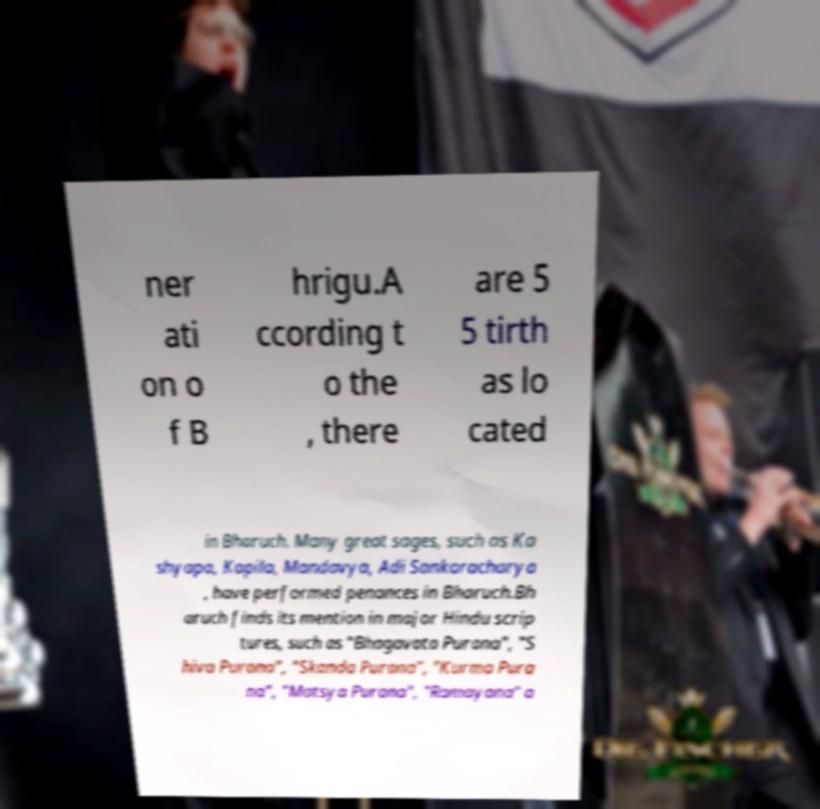Could you extract and type out the text from this image? ner ati on o f B hrigu.A ccording t o the , there are 5 5 tirth as lo cated in Bharuch. Many great sages, such as Ka shyapa, Kapila, Mandavya, Adi Sankaracharya , have performed penances in Bharuch.Bh aruch finds its mention in major Hindu scrip tures, such as "Bhagavata Purana", "S hiva Purana", "Skanda Purana", "Kurma Pura na", "Matsya Purana", "Ramayana" a 